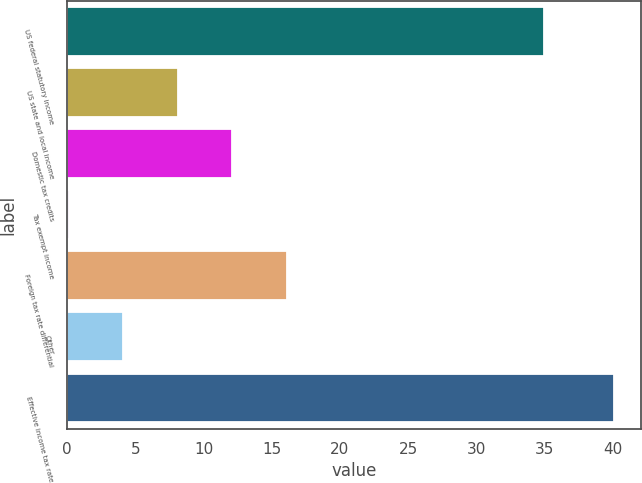Convert chart. <chart><loc_0><loc_0><loc_500><loc_500><bar_chart><fcel>US federal statutory income<fcel>US state and local income<fcel>Domestic tax credits<fcel>Tax exempt income<fcel>Foreign tax rate differential<fcel>Other<fcel>Effective income tax rate<nl><fcel>35<fcel>8.1<fcel>12.1<fcel>0.1<fcel>16.1<fcel>4.1<fcel>40.1<nl></chart> 